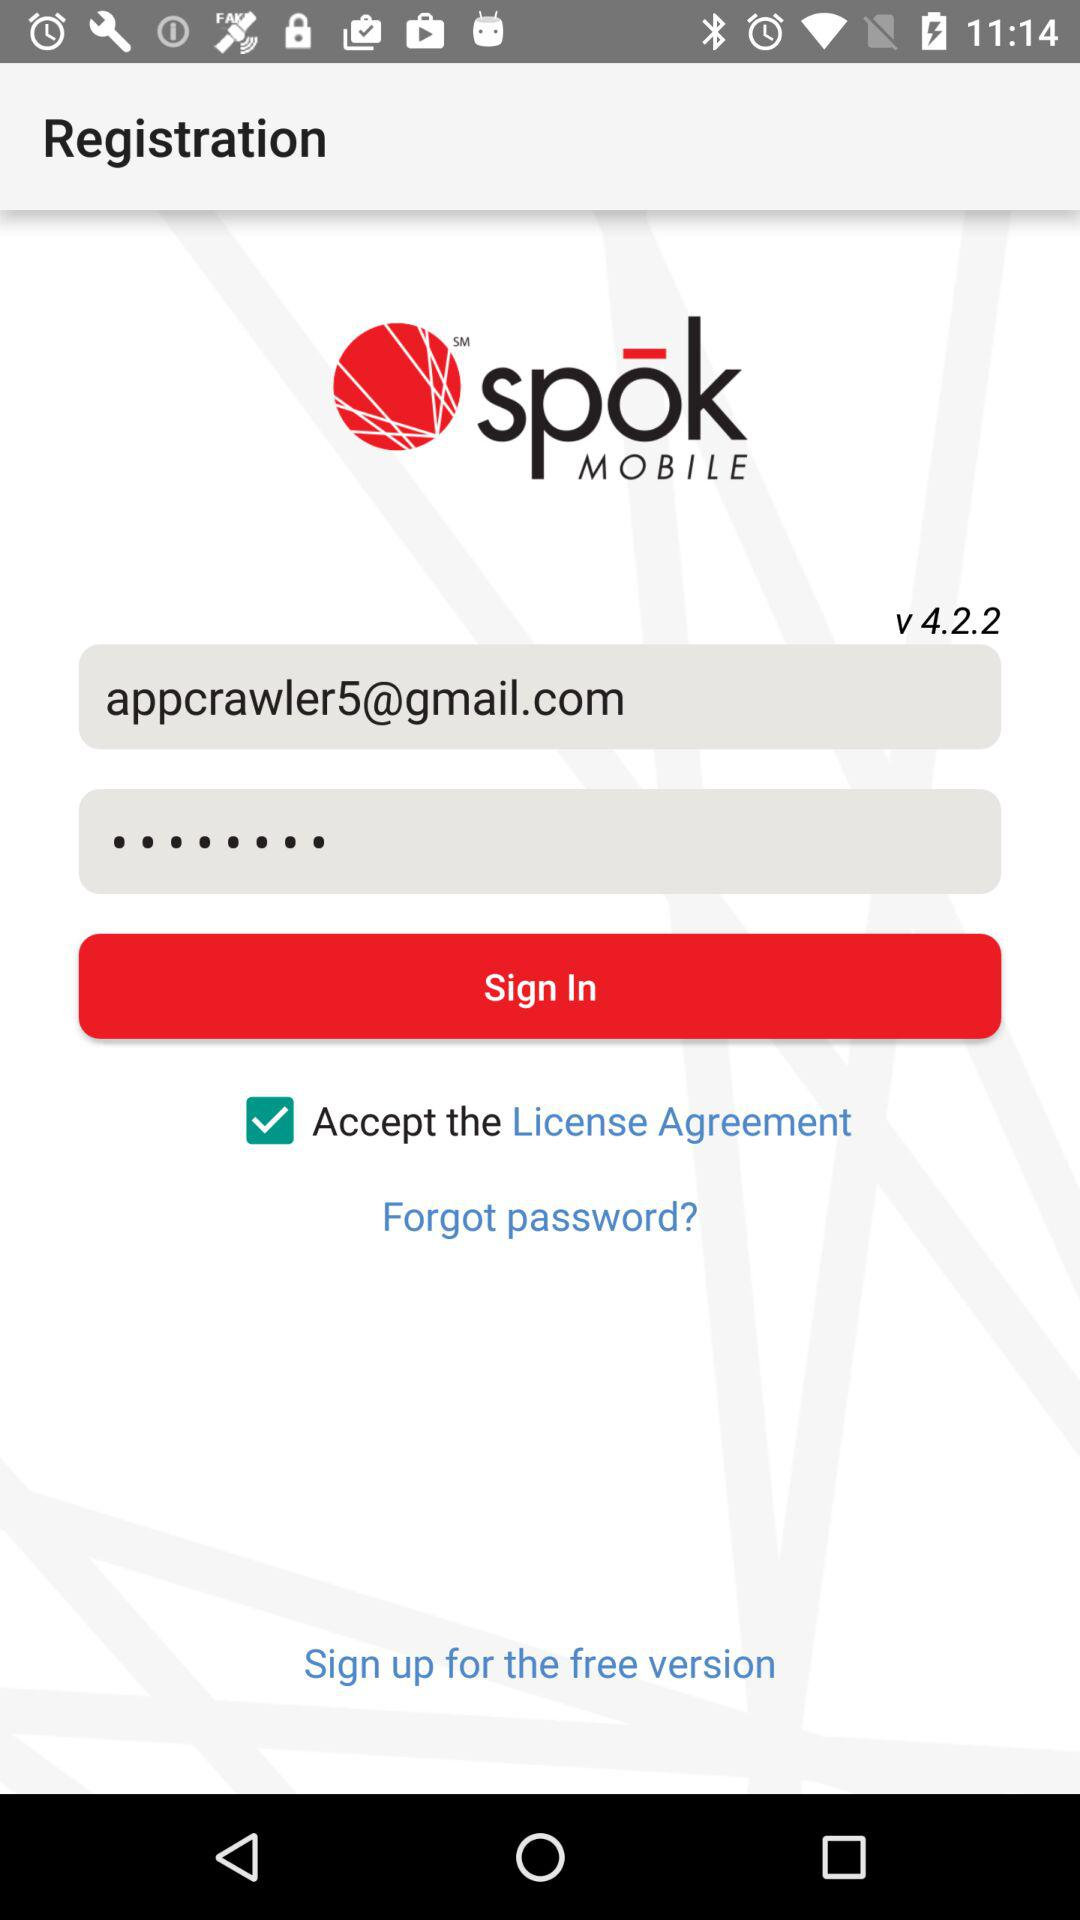What is the status of "Accept the License Agreement"? The status is "on". 